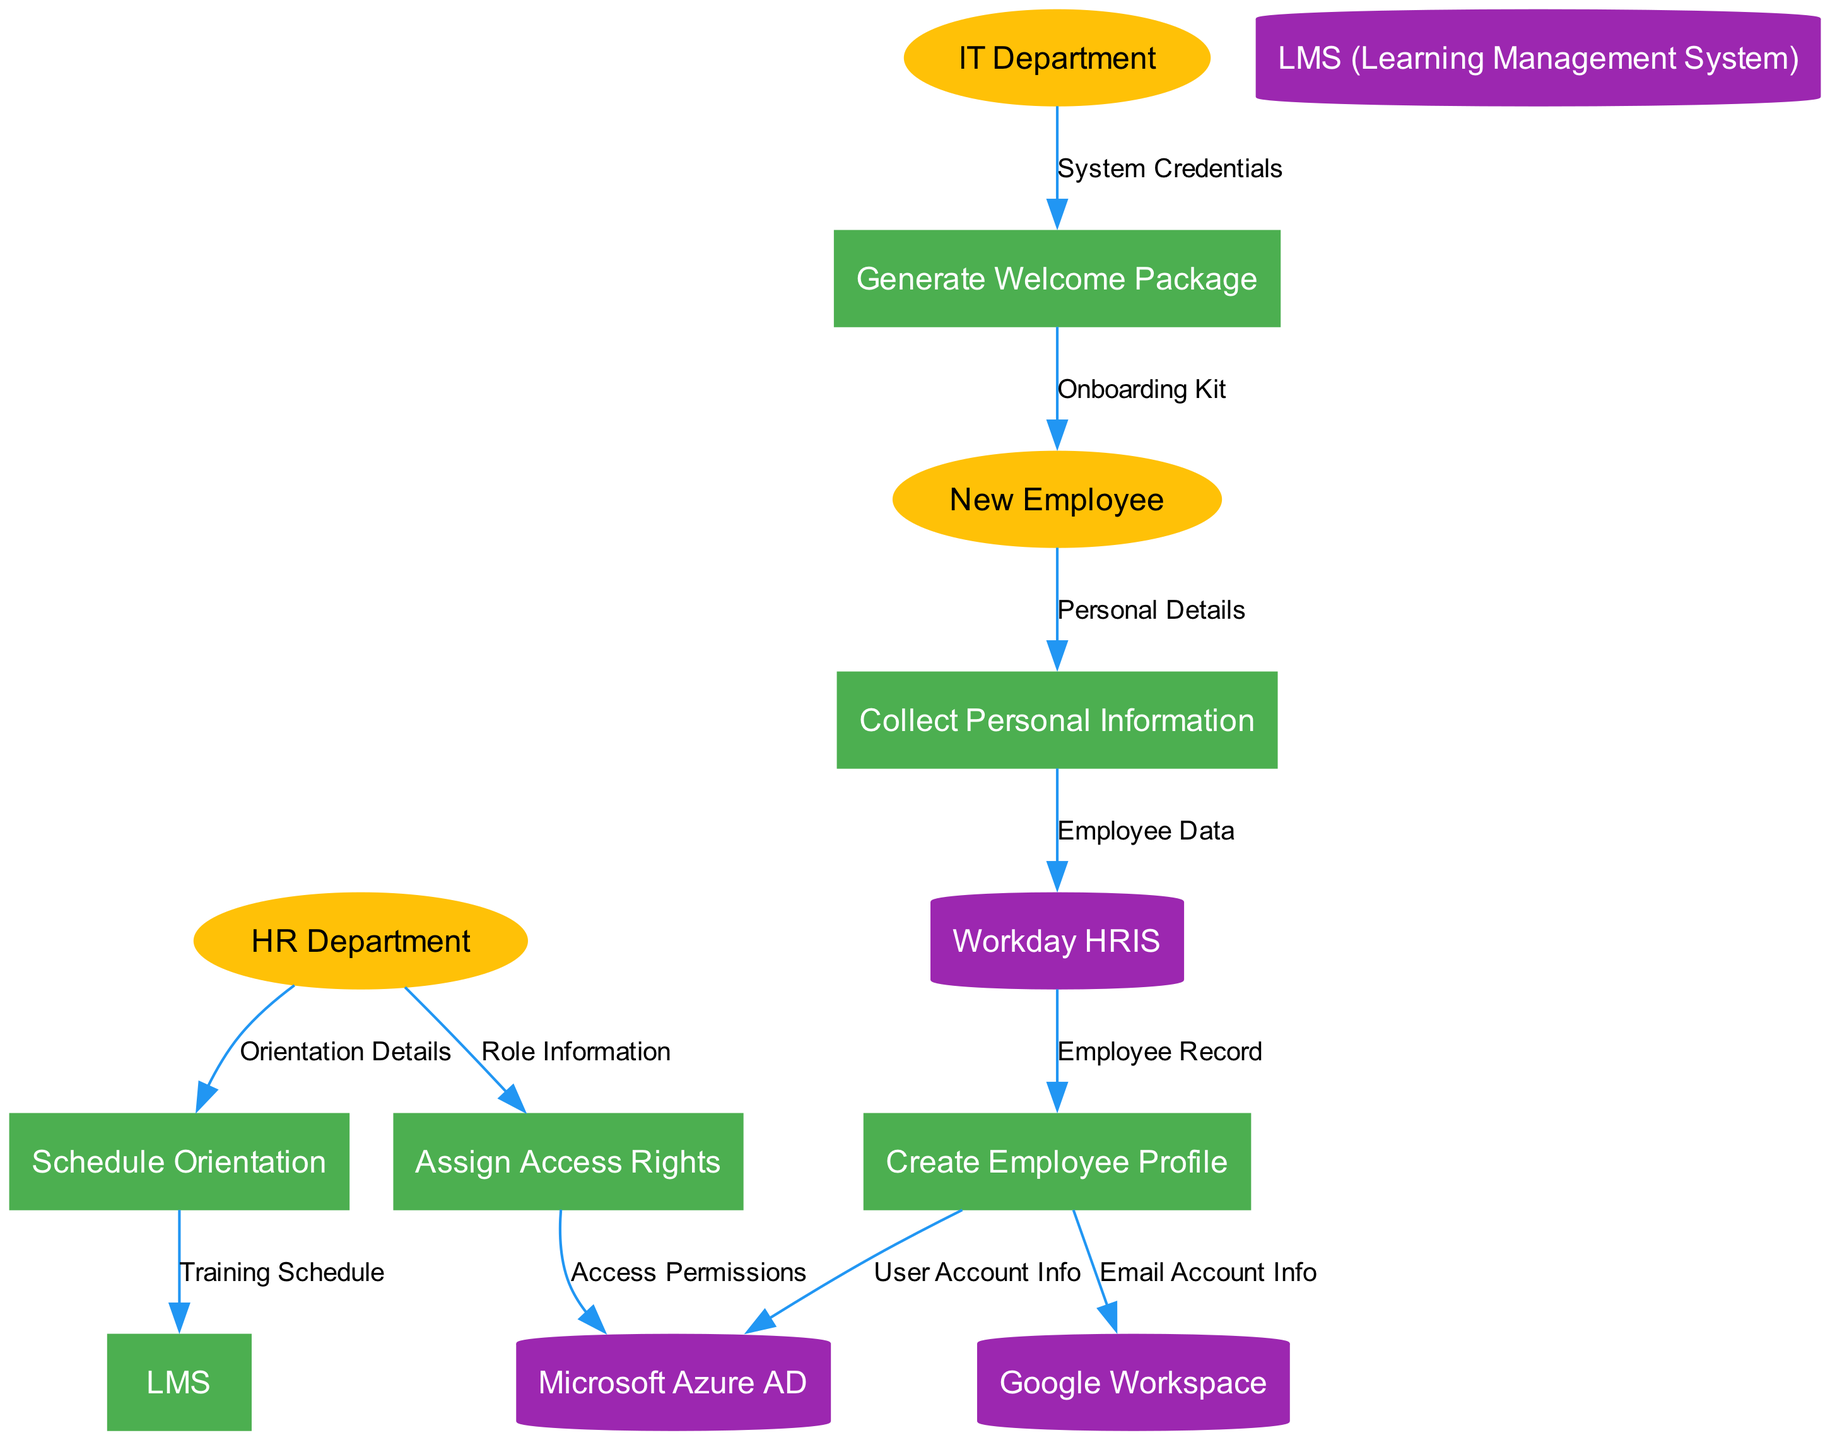What are the external entities involved in the onboarding process? The external entities listed in the diagram are the New Employee, HR Department, and IT Department. These are the key participants who interact with the processes.
Answer: New Employee, HR Department, IT Department How many processes are depicted in the diagram? The diagram includes five processes: Collect Personal Information, Create Employee Profile, Assign Access Rights, Schedule Orientation, and Generate Welcome Package. Counting these gives a total of five distinct processes.
Answer: 5 What is the data flow from the HR Department to the Assign Access Rights process? The HR Department sends Role Information to the Assign Access Rights process. This flow indicates that the HR Department provides the necessary role information for access rights assignment.
Answer: Role Information Which system receives User Account Info from the Create Employee Profile process? The Microsoft Azure AD receives User Account Info from the Create Employee Profile process. This step is crucial for setting up user accounts in the IT system.
Answer: Microsoft Azure AD What is the final deliverable sent to the New Employee? The final deliverable sent to the New Employee is the Onboarding Kit, which is generated from the Generate Welcome Package process. This kit contains essential materials for the new employee's start.
Answer: Onboarding Kit What relationship exists between the Schedule Orientation process and the LMS? The Schedule Orientation process sends a Training Schedule to the LMS. This relationship signifies that once the orientation is scheduled, the training schedule is then set in the Learning Management System for the new employee's training.
Answer: Training Schedule What data flows from the Workday HRIS to the Create Employee Profile process? The Workday HRIS sends an Employee Record to the Create Employee Profile process. This data is essential for building the employee profile based on existing records.
Answer: Employee Record Which department is responsible for generating the Welcome Package? The IT Department is responsible for generating the Welcome Package, as noted in the data flow from the IT Department to the Generate Welcome Package process. This indicates that IT plays a key role in onboarding by providing necessary information.
Answer: IT Department 